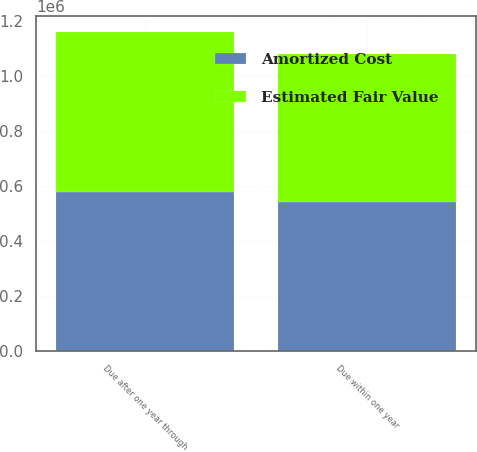Convert chart. <chart><loc_0><loc_0><loc_500><loc_500><stacked_bar_chart><ecel><fcel>Due within one year<fcel>Due after one year through<nl><fcel>Amortized Cost<fcel>541360<fcel>577978<nl><fcel>Estimated Fair Value<fcel>539406<fcel>583108<nl></chart> 